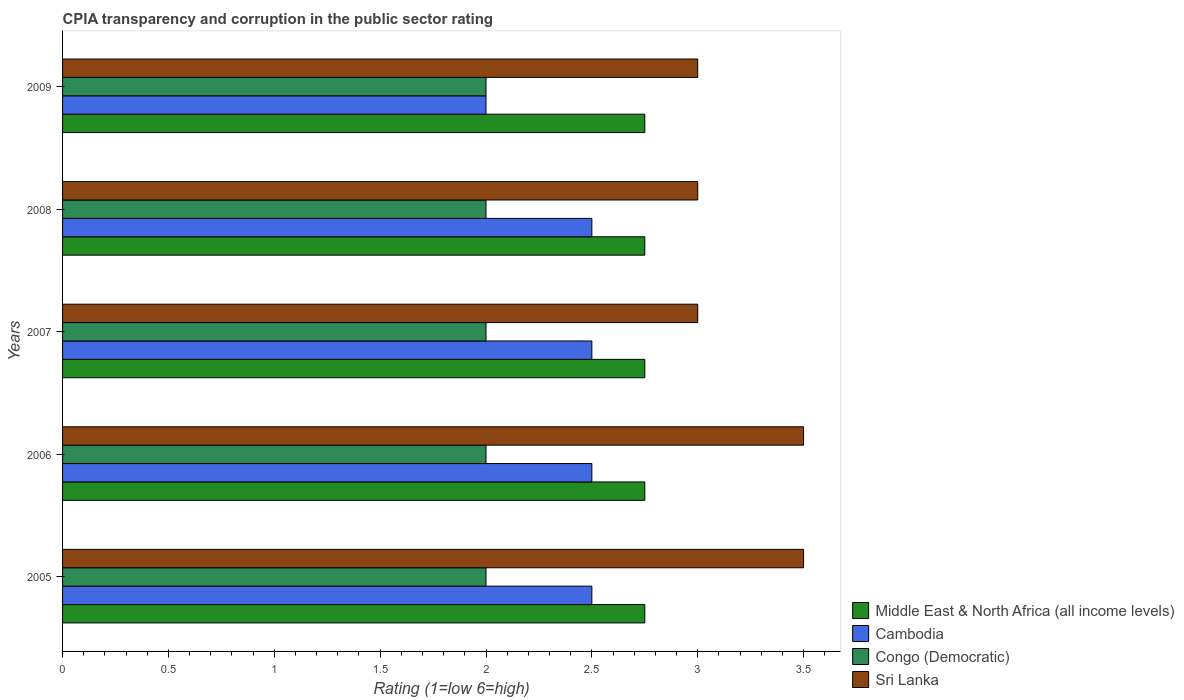How many different coloured bars are there?
Make the answer very short. 4. Are the number of bars on each tick of the Y-axis equal?
Provide a succinct answer. Yes. What is the CPIA rating in Sri Lanka in 2005?
Ensure brevity in your answer.  3.5. Across all years, what is the maximum CPIA rating in Congo (Democratic)?
Give a very brief answer. 2. Across all years, what is the minimum CPIA rating in Sri Lanka?
Make the answer very short. 3. In which year was the CPIA rating in Congo (Democratic) maximum?
Provide a succinct answer. 2005. What is the difference between the CPIA rating in Sri Lanka in 2006 and that in 2009?
Ensure brevity in your answer.  0.5. What is the average CPIA rating in Cambodia per year?
Your response must be concise. 2.4. In the year 2007, what is the difference between the CPIA rating in Sri Lanka and CPIA rating in Middle East & North Africa (all income levels)?
Provide a succinct answer. 0.25. What is the ratio of the CPIA rating in Sri Lanka in 2006 to that in 2008?
Ensure brevity in your answer.  1.17. What does the 4th bar from the top in 2005 represents?
Your answer should be very brief. Middle East & North Africa (all income levels). What does the 1st bar from the bottom in 2006 represents?
Offer a very short reply. Middle East & North Africa (all income levels). Are all the bars in the graph horizontal?
Provide a succinct answer. Yes. Are the values on the major ticks of X-axis written in scientific E-notation?
Keep it short and to the point. No. Does the graph contain grids?
Provide a short and direct response. No. Where does the legend appear in the graph?
Give a very brief answer. Bottom right. How many legend labels are there?
Offer a very short reply. 4. What is the title of the graph?
Offer a very short reply. CPIA transparency and corruption in the public sector rating. Does "Bhutan" appear as one of the legend labels in the graph?
Offer a very short reply. No. What is the label or title of the X-axis?
Provide a succinct answer. Rating (1=low 6=high). What is the Rating (1=low 6=high) in Middle East & North Africa (all income levels) in 2005?
Ensure brevity in your answer.  2.75. What is the Rating (1=low 6=high) of Cambodia in 2005?
Make the answer very short. 2.5. What is the Rating (1=low 6=high) of Middle East & North Africa (all income levels) in 2006?
Your response must be concise. 2.75. What is the Rating (1=low 6=high) of Cambodia in 2006?
Your answer should be compact. 2.5. What is the Rating (1=low 6=high) in Middle East & North Africa (all income levels) in 2007?
Offer a very short reply. 2.75. What is the Rating (1=low 6=high) in Cambodia in 2007?
Offer a terse response. 2.5. What is the Rating (1=low 6=high) in Sri Lanka in 2007?
Your response must be concise. 3. What is the Rating (1=low 6=high) in Middle East & North Africa (all income levels) in 2008?
Provide a short and direct response. 2.75. What is the Rating (1=low 6=high) in Congo (Democratic) in 2008?
Ensure brevity in your answer.  2. What is the Rating (1=low 6=high) of Middle East & North Africa (all income levels) in 2009?
Give a very brief answer. 2.75. What is the Rating (1=low 6=high) of Congo (Democratic) in 2009?
Your answer should be very brief. 2. What is the Rating (1=low 6=high) in Sri Lanka in 2009?
Your answer should be compact. 3. Across all years, what is the maximum Rating (1=low 6=high) of Middle East & North Africa (all income levels)?
Offer a terse response. 2.75. Across all years, what is the minimum Rating (1=low 6=high) in Middle East & North Africa (all income levels)?
Your answer should be very brief. 2.75. What is the total Rating (1=low 6=high) in Middle East & North Africa (all income levels) in the graph?
Provide a succinct answer. 13.75. What is the total Rating (1=low 6=high) of Cambodia in the graph?
Keep it short and to the point. 12. What is the total Rating (1=low 6=high) of Congo (Democratic) in the graph?
Your response must be concise. 10. What is the difference between the Rating (1=low 6=high) in Middle East & North Africa (all income levels) in 2005 and that in 2006?
Give a very brief answer. 0. What is the difference between the Rating (1=low 6=high) of Sri Lanka in 2005 and that in 2006?
Provide a succinct answer. 0. What is the difference between the Rating (1=low 6=high) in Congo (Democratic) in 2005 and that in 2007?
Keep it short and to the point. 0. What is the difference between the Rating (1=low 6=high) of Congo (Democratic) in 2005 and that in 2008?
Provide a succinct answer. 0. What is the difference between the Rating (1=low 6=high) in Sri Lanka in 2005 and that in 2008?
Offer a terse response. 0.5. What is the difference between the Rating (1=low 6=high) of Middle East & North Africa (all income levels) in 2005 and that in 2009?
Your answer should be compact. 0. What is the difference between the Rating (1=low 6=high) in Sri Lanka in 2005 and that in 2009?
Keep it short and to the point. 0.5. What is the difference between the Rating (1=low 6=high) in Sri Lanka in 2006 and that in 2008?
Provide a short and direct response. 0.5. What is the difference between the Rating (1=low 6=high) in Middle East & North Africa (all income levels) in 2006 and that in 2009?
Provide a succinct answer. 0. What is the difference between the Rating (1=low 6=high) of Cambodia in 2006 and that in 2009?
Provide a short and direct response. 0.5. What is the difference between the Rating (1=low 6=high) in Cambodia in 2007 and that in 2008?
Make the answer very short. 0. What is the difference between the Rating (1=low 6=high) of Cambodia in 2007 and that in 2009?
Your answer should be compact. 0.5. What is the difference between the Rating (1=low 6=high) of Congo (Democratic) in 2007 and that in 2009?
Give a very brief answer. 0. What is the difference between the Rating (1=low 6=high) in Middle East & North Africa (all income levels) in 2005 and the Rating (1=low 6=high) in Congo (Democratic) in 2006?
Ensure brevity in your answer.  0.75. What is the difference between the Rating (1=low 6=high) of Middle East & North Africa (all income levels) in 2005 and the Rating (1=low 6=high) of Sri Lanka in 2006?
Offer a terse response. -0.75. What is the difference between the Rating (1=low 6=high) in Cambodia in 2005 and the Rating (1=low 6=high) in Sri Lanka in 2006?
Provide a short and direct response. -1. What is the difference between the Rating (1=low 6=high) of Congo (Democratic) in 2005 and the Rating (1=low 6=high) of Sri Lanka in 2006?
Offer a terse response. -1.5. What is the difference between the Rating (1=low 6=high) in Middle East & North Africa (all income levels) in 2005 and the Rating (1=low 6=high) in Cambodia in 2007?
Provide a short and direct response. 0.25. What is the difference between the Rating (1=low 6=high) of Middle East & North Africa (all income levels) in 2005 and the Rating (1=low 6=high) of Congo (Democratic) in 2007?
Ensure brevity in your answer.  0.75. What is the difference between the Rating (1=low 6=high) of Middle East & North Africa (all income levels) in 2005 and the Rating (1=low 6=high) of Sri Lanka in 2007?
Provide a succinct answer. -0.25. What is the difference between the Rating (1=low 6=high) of Cambodia in 2005 and the Rating (1=low 6=high) of Sri Lanka in 2007?
Provide a short and direct response. -0.5. What is the difference between the Rating (1=low 6=high) of Congo (Democratic) in 2005 and the Rating (1=low 6=high) of Sri Lanka in 2007?
Ensure brevity in your answer.  -1. What is the difference between the Rating (1=low 6=high) in Cambodia in 2005 and the Rating (1=low 6=high) in Congo (Democratic) in 2008?
Offer a terse response. 0.5. What is the difference between the Rating (1=low 6=high) of Cambodia in 2005 and the Rating (1=low 6=high) of Sri Lanka in 2008?
Provide a succinct answer. -0.5. What is the difference between the Rating (1=low 6=high) in Middle East & North Africa (all income levels) in 2005 and the Rating (1=low 6=high) in Congo (Democratic) in 2009?
Your answer should be compact. 0.75. What is the difference between the Rating (1=low 6=high) in Cambodia in 2005 and the Rating (1=low 6=high) in Sri Lanka in 2009?
Ensure brevity in your answer.  -0.5. What is the difference between the Rating (1=low 6=high) in Congo (Democratic) in 2005 and the Rating (1=low 6=high) in Sri Lanka in 2009?
Give a very brief answer. -1. What is the difference between the Rating (1=low 6=high) of Middle East & North Africa (all income levels) in 2006 and the Rating (1=low 6=high) of Sri Lanka in 2007?
Offer a very short reply. -0.25. What is the difference between the Rating (1=low 6=high) in Cambodia in 2006 and the Rating (1=low 6=high) in Sri Lanka in 2007?
Offer a very short reply. -0.5. What is the difference between the Rating (1=low 6=high) in Congo (Democratic) in 2006 and the Rating (1=low 6=high) in Sri Lanka in 2007?
Offer a very short reply. -1. What is the difference between the Rating (1=low 6=high) in Middle East & North Africa (all income levels) in 2006 and the Rating (1=low 6=high) in Cambodia in 2008?
Give a very brief answer. 0.25. What is the difference between the Rating (1=low 6=high) in Middle East & North Africa (all income levels) in 2006 and the Rating (1=low 6=high) in Congo (Democratic) in 2008?
Provide a succinct answer. 0.75. What is the difference between the Rating (1=low 6=high) in Middle East & North Africa (all income levels) in 2006 and the Rating (1=low 6=high) in Cambodia in 2009?
Offer a terse response. 0.75. What is the difference between the Rating (1=low 6=high) of Middle East & North Africa (all income levels) in 2006 and the Rating (1=low 6=high) of Congo (Democratic) in 2009?
Make the answer very short. 0.75. What is the difference between the Rating (1=low 6=high) in Middle East & North Africa (all income levels) in 2006 and the Rating (1=low 6=high) in Sri Lanka in 2009?
Keep it short and to the point. -0.25. What is the difference between the Rating (1=low 6=high) in Cambodia in 2006 and the Rating (1=low 6=high) in Sri Lanka in 2009?
Your response must be concise. -0.5. What is the difference between the Rating (1=low 6=high) of Middle East & North Africa (all income levels) in 2007 and the Rating (1=low 6=high) of Congo (Democratic) in 2008?
Your answer should be very brief. 0.75. What is the difference between the Rating (1=low 6=high) of Middle East & North Africa (all income levels) in 2007 and the Rating (1=low 6=high) of Sri Lanka in 2008?
Offer a very short reply. -0.25. What is the difference between the Rating (1=low 6=high) in Cambodia in 2007 and the Rating (1=low 6=high) in Sri Lanka in 2008?
Provide a short and direct response. -0.5. What is the difference between the Rating (1=low 6=high) of Middle East & North Africa (all income levels) in 2007 and the Rating (1=low 6=high) of Cambodia in 2009?
Keep it short and to the point. 0.75. What is the difference between the Rating (1=low 6=high) of Middle East & North Africa (all income levels) in 2007 and the Rating (1=low 6=high) of Congo (Democratic) in 2009?
Your response must be concise. 0.75. What is the difference between the Rating (1=low 6=high) of Cambodia in 2007 and the Rating (1=low 6=high) of Sri Lanka in 2009?
Your response must be concise. -0.5. What is the difference between the Rating (1=low 6=high) in Congo (Democratic) in 2007 and the Rating (1=low 6=high) in Sri Lanka in 2009?
Your answer should be very brief. -1. What is the difference between the Rating (1=low 6=high) of Middle East & North Africa (all income levels) in 2008 and the Rating (1=low 6=high) of Sri Lanka in 2009?
Your answer should be compact. -0.25. What is the difference between the Rating (1=low 6=high) in Congo (Democratic) in 2008 and the Rating (1=low 6=high) in Sri Lanka in 2009?
Provide a short and direct response. -1. What is the average Rating (1=low 6=high) of Middle East & North Africa (all income levels) per year?
Make the answer very short. 2.75. What is the average Rating (1=low 6=high) in Cambodia per year?
Offer a very short reply. 2.4. In the year 2005, what is the difference between the Rating (1=low 6=high) of Middle East & North Africa (all income levels) and Rating (1=low 6=high) of Sri Lanka?
Offer a terse response. -0.75. In the year 2005, what is the difference between the Rating (1=low 6=high) in Cambodia and Rating (1=low 6=high) in Sri Lanka?
Make the answer very short. -1. In the year 2005, what is the difference between the Rating (1=low 6=high) in Congo (Democratic) and Rating (1=low 6=high) in Sri Lanka?
Your answer should be compact. -1.5. In the year 2006, what is the difference between the Rating (1=low 6=high) of Middle East & North Africa (all income levels) and Rating (1=low 6=high) of Congo (Democratic)?
Give a very brief answer. 0.75. In the year 2006, what is the difference between the Rating (1=low 6=high) of Middle East & North Africa (all income levels) and Rating (1=low 6=high) of Sri Lanka?
Your answer should be very brief. -0.75. In the year 2007, what is the difference between the Rating (1=low 6=high) of Middle East & North Africa (all income levels) and Rating (1=low 6=high) of Congo (Democratic)?
Make the answer very short. 0.75. In the year 2007, what is the difference between the Rating (1=low 6=high) in Middle East & North Africa (all income levels) and Rating (1=low 6=high) in Sri Lanka?
Your response must be concise. -0.25. In the year 2008, what is the difference between the Rating (1=low 6=high) in Middle East & North Africa (all income levels) and Rating (1=low 6=high) in Congo (Democratic)?
Make the answer very short. 0.75. In the year 2008, what is the difference between the Rating (1=low 6=high) in Cambodia and Rating (1=low 6=high) in Sri Lanka?
Offer a terse response. -0.5. In the year 2008, what is the difference between the Rating (1=low 6=high) of Congo (Democratic) and Rating (1=low 6=high) of Sri Lanka?
Your response must be concise. -1. In the year 2009, what is the difference between the Rating (1=low 6=high) in Middle East & North Africa (all income levels) and Rating (1=low 6=high) in Cambodia?
Offer a terse response. 0.75. In the year 2009, what is the difference between the Rating (1=low 6=high) of Middle East & North Africa (all income levels) and Rating (1=low 6=high) of Congo (Democratic)?
Give a very brief answer. 0.75. In the year 2009, what is the difference between the Rating (1=low 6=high) of Middle East & North Africa (all income levels) and Rating (1=low 6=high) of Sri Lanka?
Provide a succinct answer. -0.25. In the year 2009, what is the difference between the Rating (1=low 6=high) in Cambodia and Rating (1=low 6=high) in Congo (Democratic)?
Provide a short and direct response. 0. What is the ratio of the Rating (1=low 6=high) of Cambodia in 2005 to that in 2006?
Ensure brevity in your answer.  1. What is the ratio of the Rating (1=low 6=high) of Congo (Democratic) in 2005 to that in 2006?
Your answer should be very brief. 1. What is the ratio of the Rating (1=low 6=high) in Sri Lanka in 2005 to that in 2006?
Give a very brief answer. 1. What is the ratio of the Rating (1=low 6=high) of Congo (Democratic) in 2005 to that in 2007?
Your answer should be compact. 1. What is the ratio of the Rating (1=low 6=high) in Sri Lanka in 2005 to that in 2007?
Your answer should be compact. 1.17. What is the ratio of the Rating (1=low 6=high) of Middle East & North Africa (all income levels) in 2005 to that in 2009?
Provide a short and direct response. 1. What is the ratio of the Rating (1=low 6=high) in Cambodia in 2005 to that in 2009?
Your response must be concise. 1.25. What is the ratio of the Rating (1=low 6=high) in Congo (Democratic) in 2005 to that in 2009?
Offer a terse response. 1. What is the ratio of the Rating (1=low 6=high) in Sri Lanka in 2005 to that in 2009?
Provide a succinct answer. 1.17. What is the ratio of the Rating (1=low 6=high) in Middle East & North Africa (all income levels) in 2006 to that in 2008?
Your response must be concise. 1. What is the ratio of the Rating (1=low 6=high) of Cambodia in 2006 to that in 2008?
Ensure brevity in your answer.  1. What is the ratio of the Rating (1=low 6=high) of Sri Lanka in 2006 to that in 2008?
Make the answer very short. 1.17. What is the ratio of the Rating (1=low 6=high) of Middle East & North Africa (all income levels) in 2006 to that in 2009?
Provide a short and direct response. 1. What is the ratio of the Rating (1=low 6=high) in Sri Lanka in 2006 to that in 2009?
Your response must be concise. 1.17. What is the ratio of the Rating (1=low 6=high) of Congo (Democratic) in 2007 to that in 2008?
Offer a very short reply. 1. What is the ratio of the Rating (1=low 6=high) in Sri Lanka in 2007 to that in 2008?
Make the answer very short. 1. What is the ratio of the Rating (1=low 6=high) in Middle East & North Africa (all income levels) in 2007 to that in 2009?
Make the answer very short. 1. What is the ratio of the Rating (1=low 6=high) in Cambodia in 2007 to that in 2009?
Provide a succinct answer. 1.25. What is the ratio of the Rating (1=low 6=high) of Cambodia in 2008 to that in 2009?
Make the answer very short. 1.25. What is the ratio of the Rating (1=low 6=high) in Congo (Democratic) in 2008 to that in 2009?
Offer a very short reply. 1. What is the difference between the highest and the second highest Rating (1=low 6=high) of Middle East & North Africa (all income levels)?
Your answer should be very brief. 0. What is the difference between the highest and the second highest Rating (1=low 6=high) of Cambodia?
Offer a very short reply. 0. What is the difference between the highest and the second highest Rating (1=low 6=high) of Congo (Democratic)?
Your response must be concise. 0. What is the difference between the highest and the second highest Rating (1=low 6=high) of Sri Lanka?
Offer a very short reply. 0. What is the difference between the highest and the lowest Rating (1=low 6=high) of Middle East & North Africa (all income levels)?
Provide a succinct answer. 0. What is the difference between the highest and the lowest Rating (1=low 6=high) in Sri Lanka?
Your answer should be very brief. 0.5. 